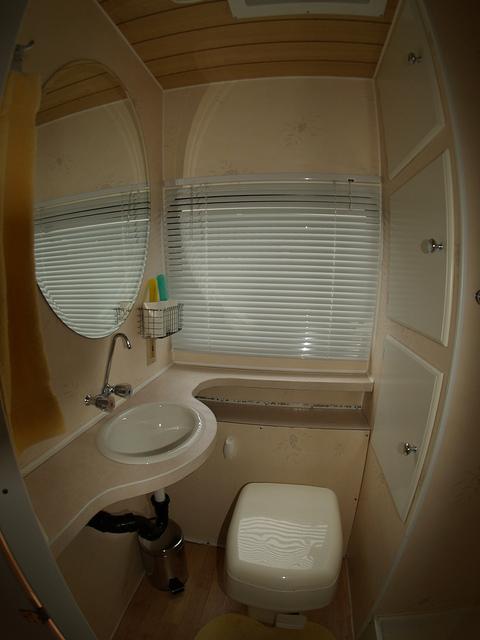Does the mirror at the top light up?
Quick response, please. No. Where is bathroom located?
Keep it brief. House. How many cabinets are visible?
Short answer required. 3. How many towels are in this picture?
Concise answer only. 0. Is this a small bathroom?
Answer briefly. Yes. What kind of cover is on the window?
Concise answer only. Blinds. What is showing on the window?
Write a very short answer. Blinds. 